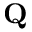Convert formula to latex. <formula><loc_0><loc_0><loc_500><loc_500>Q</formula> 